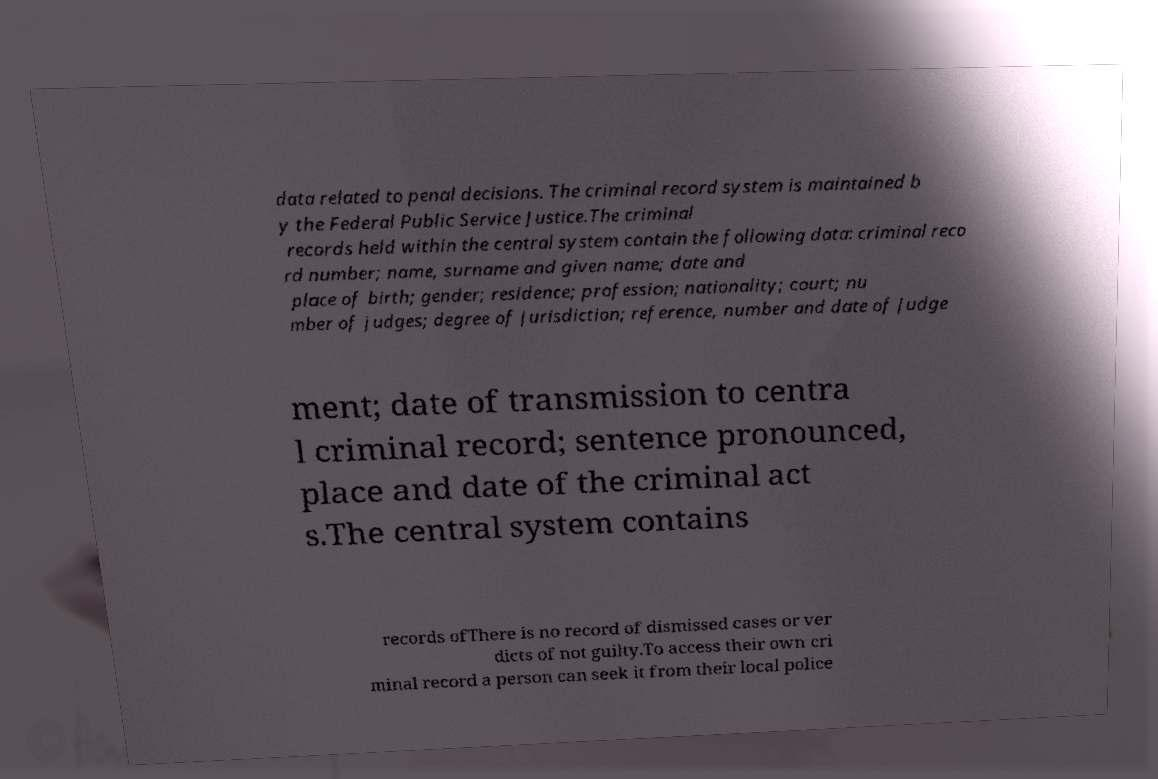Could you assist in decoding the text presented in this image and type it out clearly? data related to penal decisions. The criminal record system is maintained b y the Federal Public Service Justice.The criminal records held within the central system contain the following data: criminal reco rd number; name, surname and given name; date and place of birth; gender; residence; profession; nationality; court; nu mber of judges; degree of jurisdiction; reference, number and date of judge ment; date of transmission to centra l criminal record; sentence pronounced, place and date of the criminal act s.The central system contains records ofThere is no record of dismissed cases or ver dicts of not guilty.To access their own cri minal record a person can seek it from their local police 